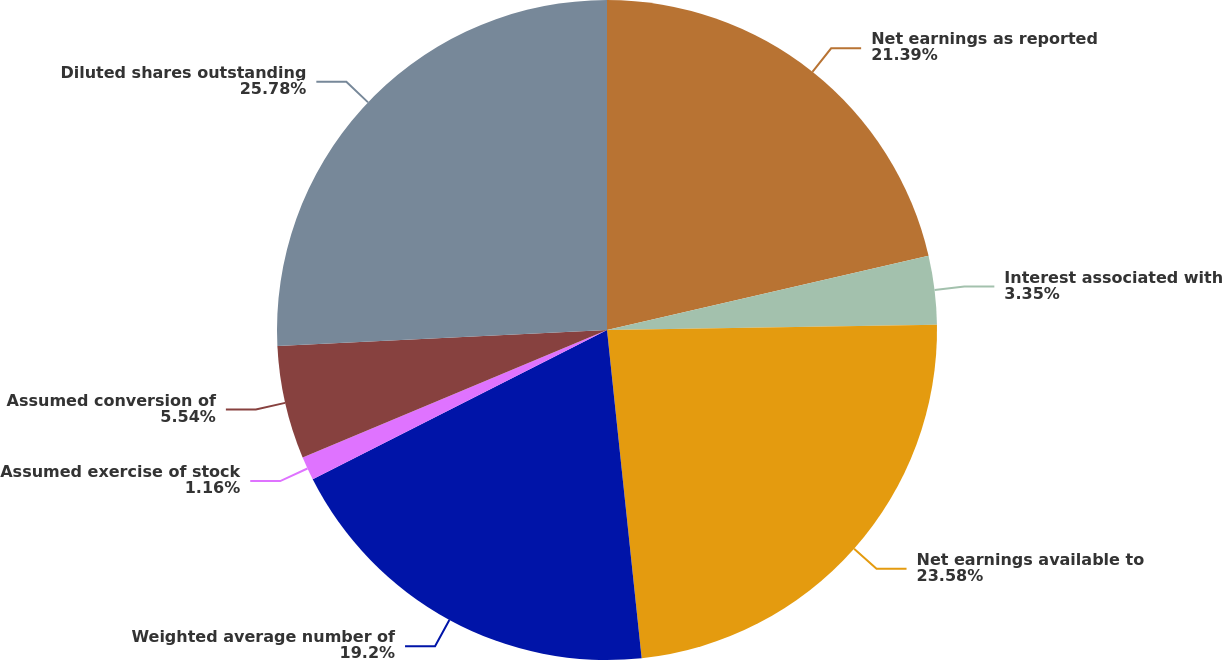Convert chart to OTSL. <chart><loc_0><loc_0><loc_500><loc_500><pie_chart><fcel>Net earnings as reported<fcel>Interest associated with<fcel>Net earnings available to<fcel>Weighted average number of<fcel>Assumed exercise of stock<fcel>Assumed conversion of<fcel>Diluted shares outstanding<nl><fcel>21.39%<fcel>3.35%<fcel>23.58%<fcel>19.2%<fcel>1.16%<fcel>5.54%<fcel>25.77%<nl></chart> 